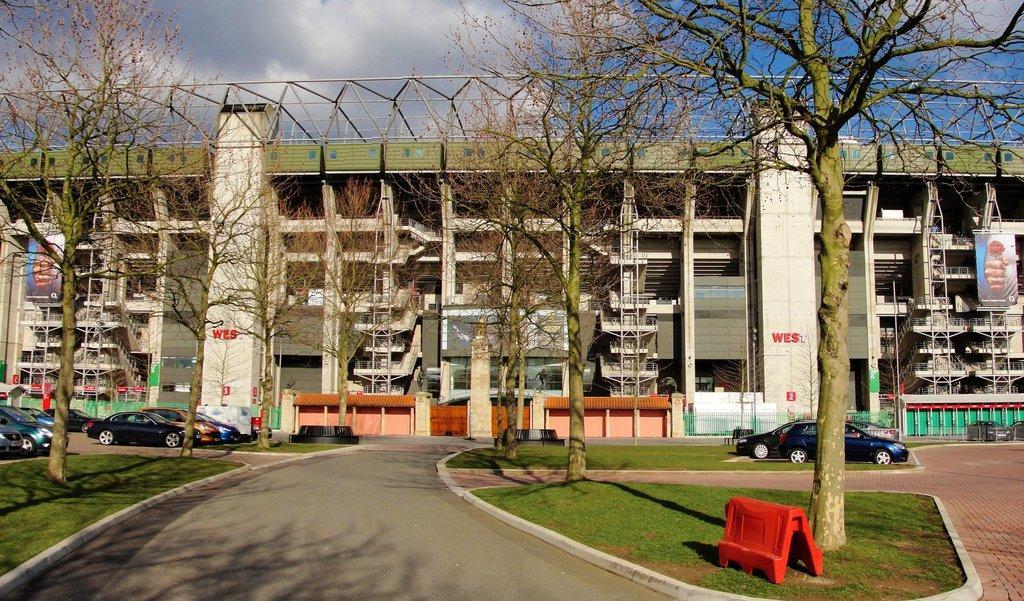In one or two sentences, can you explain what this image depicts? In this image, on the right side, we can see some trees and a red color board and two cars which are placed on the grass. On the right side, we can also see some hoardings, vehicles, building. In the middle of the image, we can see some trees, building. On the left side, we can see some trees, few cars which are placed on the road, hoardings, buildings. In the background, we can also see a building. At the top, we can see a sky which is cloudy, at the bottom, we can see a road and a grass. 